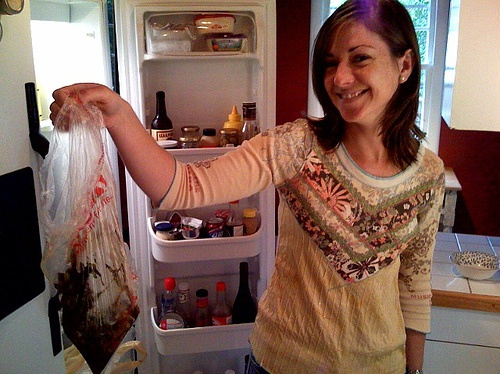Describe the objects in this image and their specific colors. I can see refrigerator in black, gray, and darkgray tones, people in black, brown, and maroon tones, bottle in black, brown, and purple tones, bowl in black, gray, and darkgray tones, and bottle in black, maroon, brown, and gray tones in this image. 